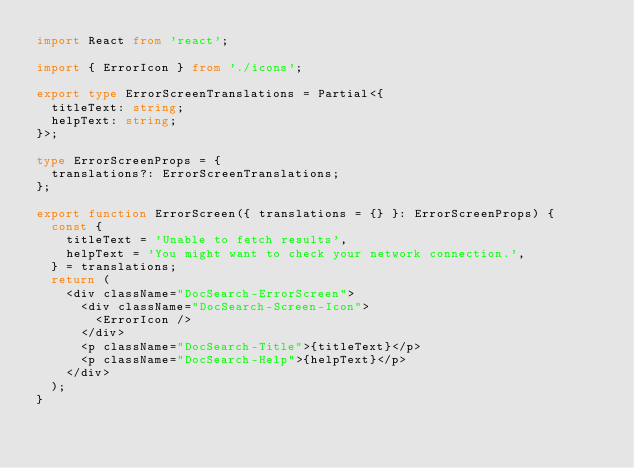Convert code to text. <code><loc_0><loc_0><loc_500><loc_500><_TypeScript_>import React from 'react';

import { ErrorIcon } from './icons';

export type ErrorScreenTranslations = Partial<{
  titleText: string;
  helpText: string;
}>;

type ErrorScreenProps = {
  translations?: ErrorScreenTranslations;
};

export function ErrorScreen({ translations = {} }: ErrorScreenProps) {
  const {
    titleText = 'Unable to fetch results',
    helpText = 'You might want to check your network connection.',
  } = translations;
  return (
    <div className="DocSearch-ErrorScreen">
      <div className="DocSearch-Screen-Icon">
        <ErrorIcon />
      </div>
      <p className="DocSearch-Title">{titleText}</p>
      <p className="DocSearch-Help">{helpText}</p>
    </div>
  );
}
</code> 